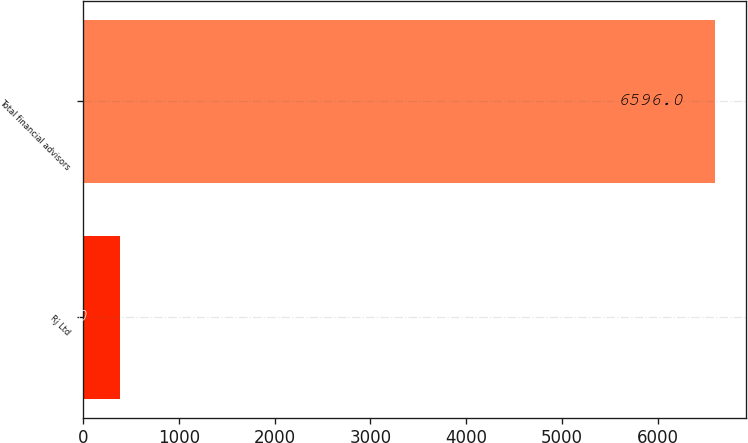Convert chart to OTSL. <chart><loc_0><loc_0><loc_500><loc_500><bar_chart><fcel>RJ Ltd<fcel>Total financial advisors<nl><fcel>383<fcel>6596<nl></chart> 